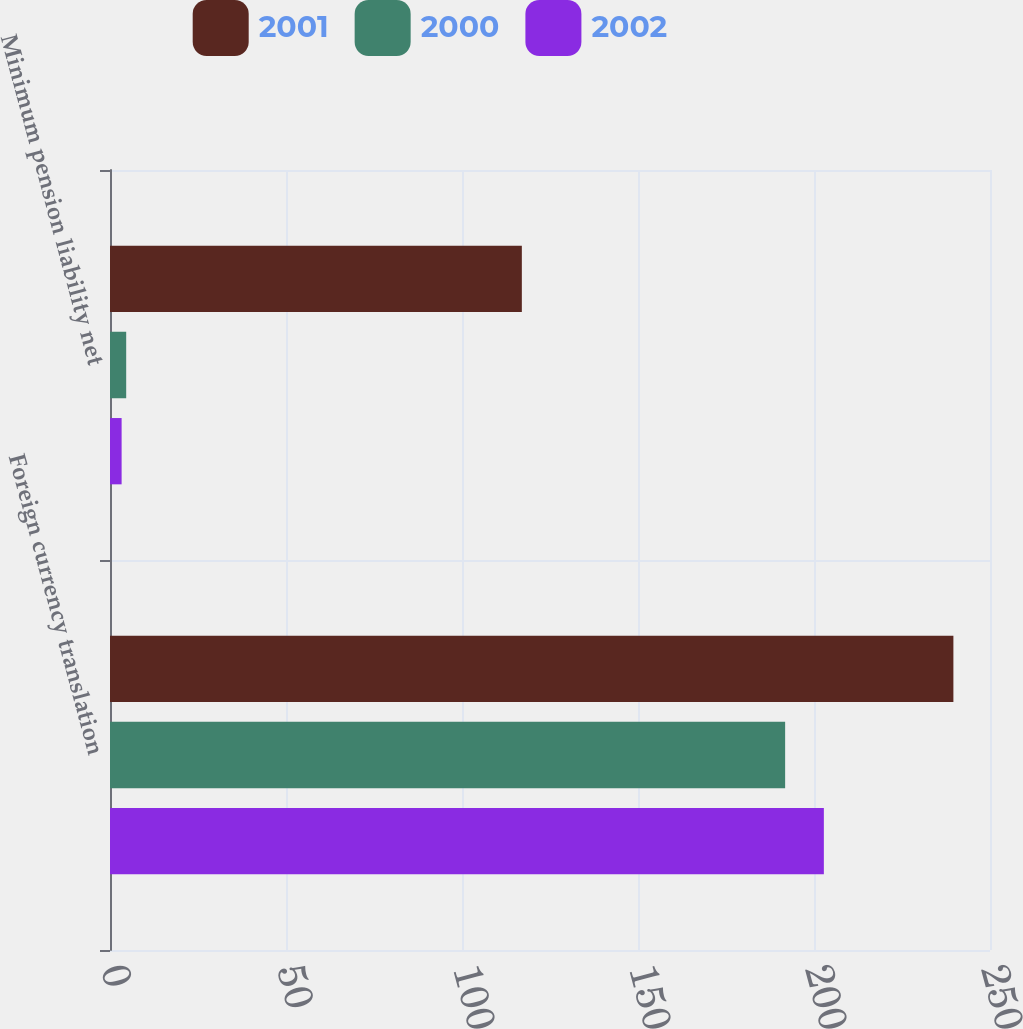Convert chart to OTSL. <chart><loc_0><loc_0><loc_500><loc_500><stacked_bar_chart><ecel><fcel>Foreign currency translation<fcel>Minimum pension liability net<nl><fcel>2001<fcel>239.6<fcel>117<nl><fcel>2000<fcel>191.8<fcel>4.6<nl><fcel>2002<fcel>202.8<fcel>3.3<nl></chart> 